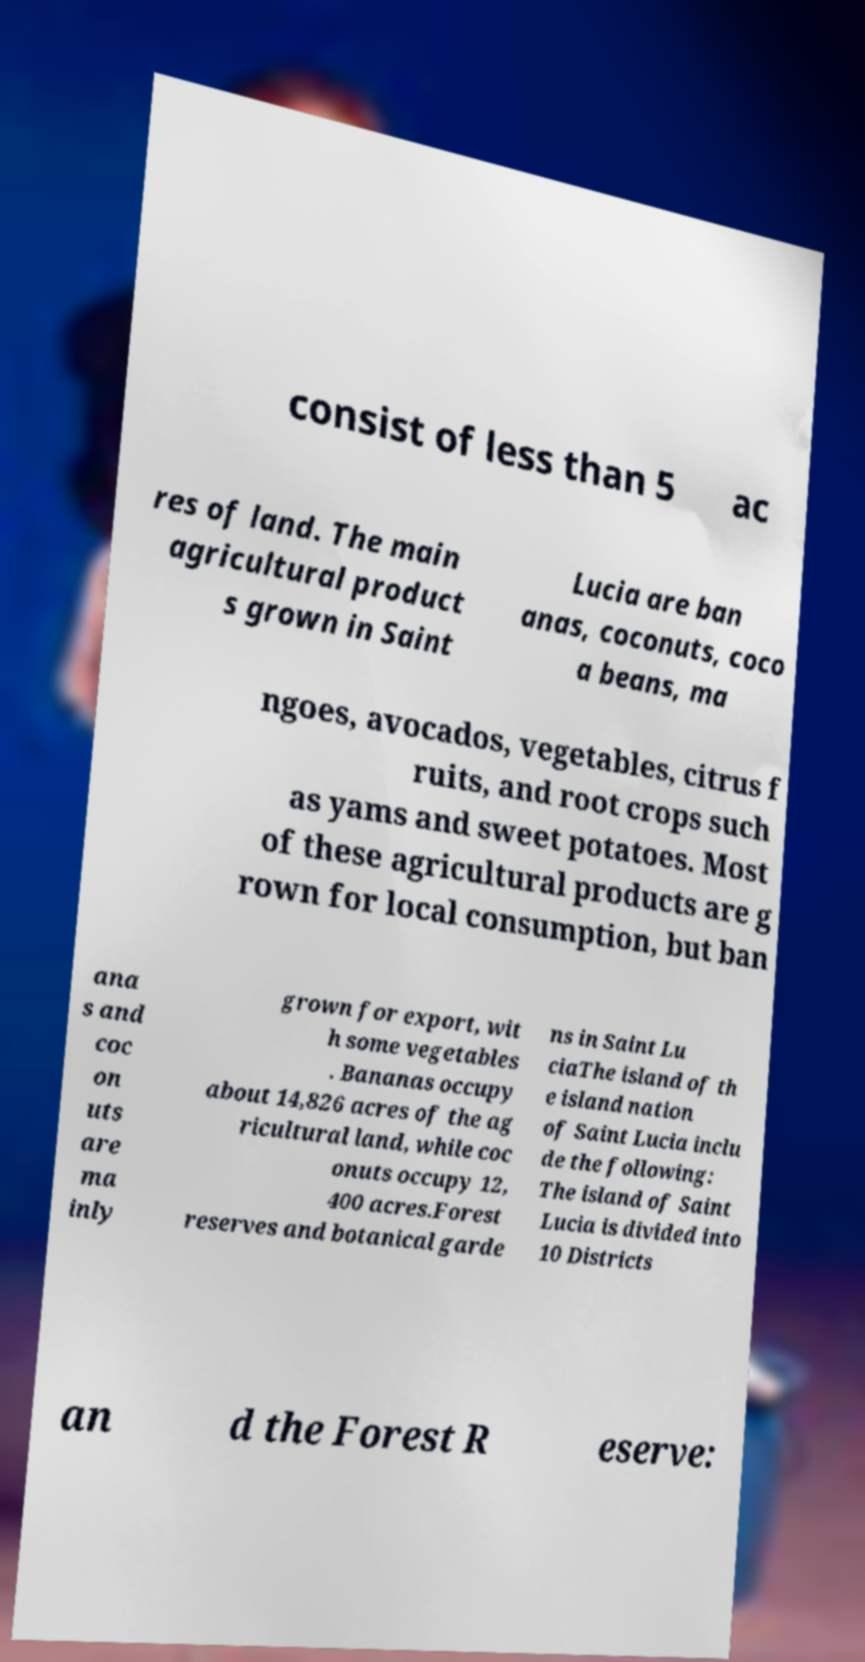Could you extract and type out the text from this image? consist of less than 5 ac res of land. The main agricultural product s grown in Saint Lucia are ban anas, coconuts, coco a beans, ma ngoes, avocados, vegetables, citrus f ruits, and root crops such as yams and sweet potatoes. Most of these agricultural products are g rown for local consumption, but ban ana s and coc on uts are ma inly grown for export, wit h some vegetables . Bananas occupy about 14,826 acres of the ag ricultural land, while coc onuts occupy 12, 400 acres.Forest reserves and botanical garde ns in Saint Lu ciaThe island of th e island nation of Saint Lucia inclu de the following: The island of Saint Lucia is divided into 10 Districts an d the Forest R eserve: 